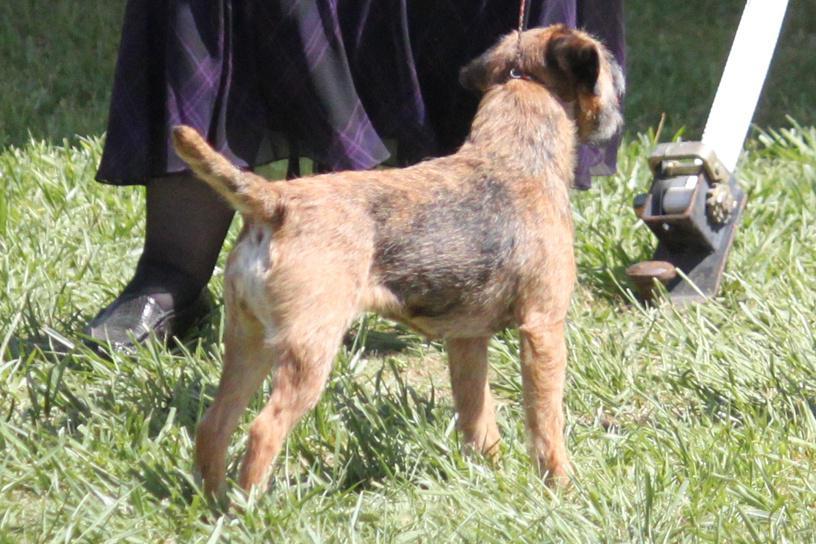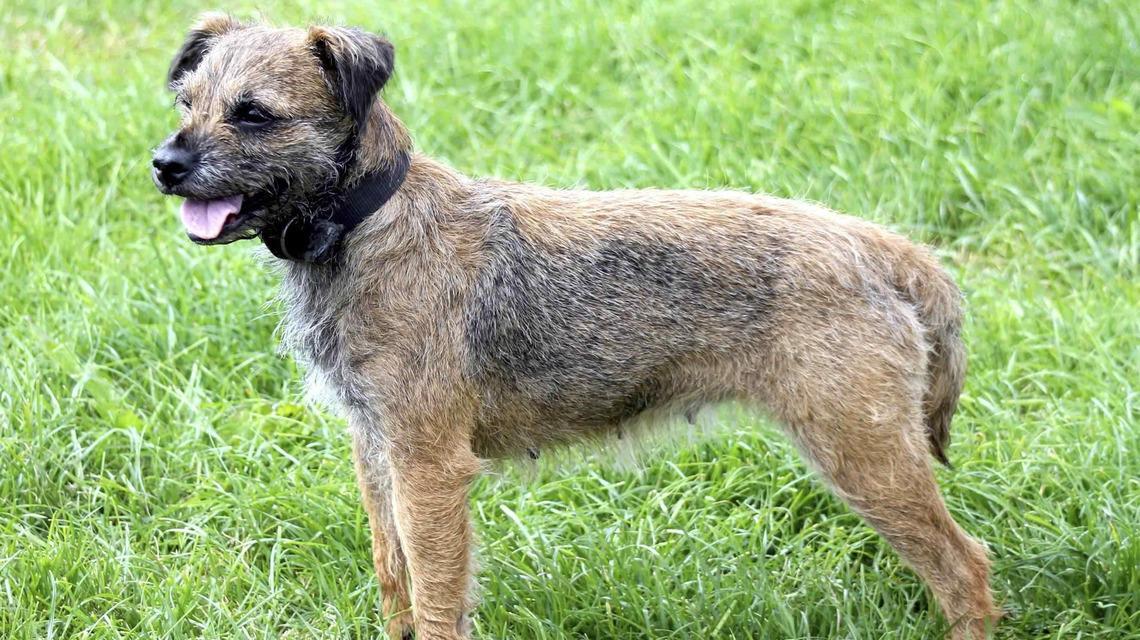The first image is the image on the left, the second image is the image on the right. Given the left and right images, does the statement "The right image contains one dog standing in the grass with its tail hanging down, its mouth open, and something around its neck." hold true? Answer yes or no. Yes. The first image is the image on the left, the second image is the image on the right. Evaluate the accuracy of this statement regarding the images: "There is exactly one dog in every photo and no dogs have their mouths open.". Is it true? Answer yes or no. No. 